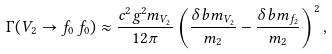<formula> <loc_0><loc_0><loc_500><loc_500>\Gamma ( V _ { 2 } \to f _ { 0 } \, f _ { 0 } ) \approx \frac { c ^ { 2 } g ^ { 2 } m _ { V _ { 2 } } } { 1 2 \pi } \left ( \frac { \delta b m _ { V _ { 2 } } } { m _ { 2 } } - \frac { \delta b m _ { f _ { 2 } } } { m _ { 2 } } \right ) ^ { 2 } ,</formula> 